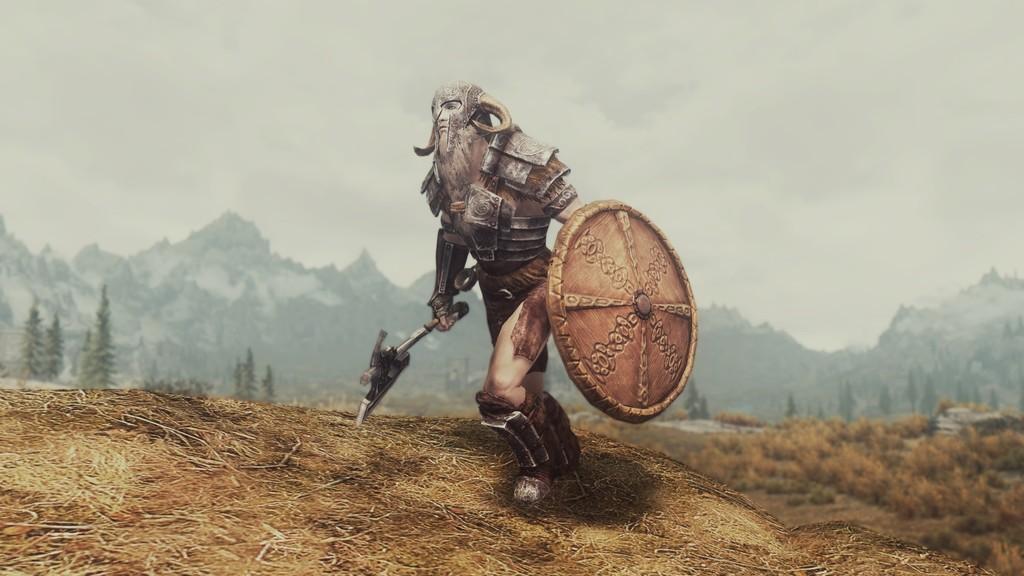Could you give a brief overview of what you see in this image? In this image I can see depiction of a warrior, number of trees, mountains and the sky. 